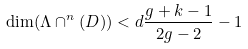<formula> <loc_0><loc_0><loc_500><loc_500>\dim ( \Lambda \cap ^ { n } ( D ) ) < d \frac { g + k - 1 } { 2 g - 2 } - 1</formula> 